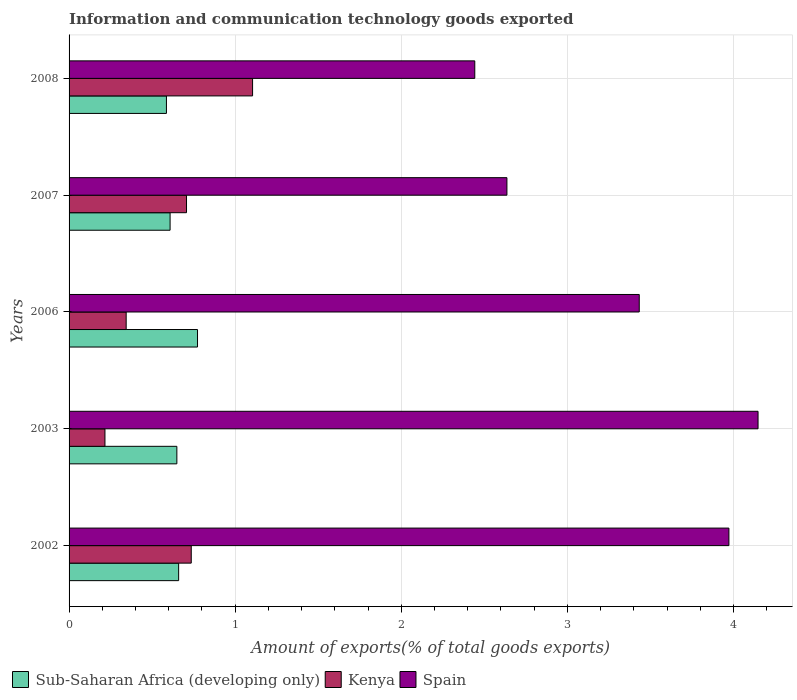How many groups of bars are there?
Provide a short and direct response. 5. Are the number of bars on each tick of the Y-axis equal?
Offer a terse response. Yes. How many bars are there on the 4th tick from the bottom?
Your answer should be compact. 3. What is the amount of goods exported in Sub-Saharan Africa (developing only) in 2002?
Provide a succinct answer. 0.66. Across all years, what is the maximum amount of goods exported in Sub-Saharan Africa (developing only)?
Keep it short and to the point. 0.77. Across all years, what is the minimum amount of goods exported in Spain?
Offer a terse response. 2.44. In which year was the amount of goods exported in Spain minimum?
Keep it short and to the point. 2008. What is the total amount of goods exported in Kenya in the graph?
Your answer should be compact. 3.11. What is the difference between the amount of goods exported in Kenya in 2002 and that in 2006?
Make the answer very short. 0.39. What is the difference between the amount of goods exported in Spain in 2008 and the amount of goods exported in Sub-Saharan Africa (developing only) in 2002?
Provide a short and direct response. 1.78. What is the average amount of goods exported in Kenya per year?
Offer a terse response. 0.62. In the year 2002, what is the difference between the amount of goods exported in Sub-Saharan Africa (developing only) and amount of goods exported in Kenya?
Provide a succinct answer. -0.08. In how many years, is the amount of goods exported in Spain greater than 3 %?
Give a very brief answer. 3. What is the ratio of the amount of goods exported in Kenya in 2002 to that in 2003?
Offer a terse response. 3.41. What is the difference between the highest and the second highest amount of goods exported in Sub-Saharan Africa (developing only)?
Keep it short and to the point. 0.11. What is the difference between the highest and the lowest amount of goods exported in Sub-Saharan Africa (developing only)?
Offer a terse response. 0.19. In how many years, is the amount of goods exported in Spain greater than the average amount of goods exported in Spain taken over all years?
Your answer should be compact. 3. What does the 2nd bar from the top in 2003 represents?
Your response must be concise. Kenya. What does the 2nd bar from the bottom in 2003 represents?
Your response must be concise. Kenya. Is it the case that in every year, the sum of the amount of goods exported in Spain and amount of goods exported in Kenya is greater than the amount of goods exported in Sub-Saharan Africa (developing only)?
Provide a short and direct response. Yes. How many bars are there?
Provide a succinct answer. 15. Are all the bars in the graph horizontal?
Keep it short and to the point. Yes. Are the values on the major ticks of X-axis written in scientific E-notation?
Offer a terse response. No. Does the graph contain grids?
Offer a very short reply. Yes. Where does the legend appear in the graph?
Make the answer very short. Bottom left. How many legend labels are there?
Your response must be concise. 3. How are the legend labels stacked?
Offer a terse response. Horizontal. What is the title of the graph?
Offer a terse response. Information and communication technology goods exported. What is the label or title of the X-axis?
Your answer should be very brief. Amount of exports(% of total goods exports). What is the label or title of the Y-axis?
Offer a very short reply. Years. What is the Amount of exports(% of total goods exports) in Sub-Saharan Africa (developing only) in 2002?
Keep it short and to the point. 0.66. What is the Amount of exports(% of total goods exports) in Kenya in 2002?
Ensure brevity in your answer.  0.74. What is the Amount of exports(% of total goods exports) in Spain in 2002?
Keep it short and to the point. 3.97. What is the Amount of exports(% of total goods exports) in Sub-Saharan Africa (developing only) in 2003?
Offer a very short reply. 0.65. What is the Amount of exports(% of total goods exports) of Kenya in 2003?
Your response must be concise. 0.22. What is the Amount of exports(% of total goods exports) of Spain in 2003?
Give a very brief answer. 4.15. What is the Amount of exports(% of total goods exports) in Sub-Saharan Africa (developing only) in 2006?
Your answer should be compact. 0.77. What is the Amount of exports(% of total goods exports) of Kenya in 2006?
Offer a very short reply. 0.34. What is the Amount of exports(% of total goods exports) of Spain in 2006?
Keep it short and to the point. 3.43. What is the Amount of exports(% of total goods exports) in Sub-Saharan Africa (developing only) in 2007?
Ensure brevity in your answer.  0.61. What is the Amount of exports(% of total goods exports) in Kenya in 2007?
Keep it short and to the point. 0.71. What is the Amount of exports(% of total goods exports) of Spain in 2007?
Keep it short and to the point. 2.64. What is the Amount of exports(% of total goods exports) of Sub-Saharan Africa (developing only) in 2008?
Keep it short and to the point. 0.59. What is the Amount of exports(% of total goods exports) in Kenya in 2008?
Your answer should be compact. 1.1. What is the Amount of exports(% of total goods exports) of Spain in 2008?
Keep it short and to the point. 2.44. Across all years, what is the maximum Amount of exports(% of total goods exports) of Sub-Saharan Africa (developing only)?
Your answer should be compact. 0.77. Across all years, what is the maximum Amount of exports(% of total goods exports) of Kenya?
Your response must be concise. 1.1. Across all years, what is the maximum Amount of exports(% of total goods exports) in Spain?
Ensure brevity in your answer.  4.15. Across all years, what is the minimum Amount of exports(% of total goods exports) in Sub-Saharan Africa (developing only)?
Make the answer very short. 0.59. Across all years, what is the minimum Amount of exports(% of total goods exports) of Kenya?
Your response must be concise. 0.22. Across all years, what is the minimum Amount of exports(% of total goods exports) of Spain?
Offer a terse response. 2.44. What is the total Amount of exports(% of total goods exports) in Sub-Saharan Africa (developing only) in the graph?
Provide a short and direct response. 3.28. What is the total Amount of exports(% of total goods exports) in Kenya in the graph?
Keep it short and to the point. 3.11. What is the total Amount of exports(% of total goods exports) in Spain in the graph?
Offer a very short reply. 16.63. What is the difference between the Amount of exports(% of total goods exports) of Sub-Saharan Africa (developing only) in 2002 and that in 2003?
Keep it short and to the point. 0.01. What is the difference between the Amount of exports(% of total goods exports) of Kenya in 2002 and that in 2003?
Provide a short and direct response. 0.52. What is the difference between the Amount of exports(% of total goods exports) of Spain in 2002 and that in 2003?
Offer a very short reply. -0.18. What is the difference between the Amount of exports(% of total goods exports) in Sub-Saharan Africa (developing only) in 2002 and that in 2006?
Provide a short and direct response. -0.11. What is the difference between the Amount of exports(% of total goods exports) in Kenya in 2002 and that in 2006?
Offer a very short reply. 0.39. What is the difference between the Amount of exports(% of total goods exports) in Spain in 2002 and that in 2006?
Provide a short and direct response. 0.54. What is the difference between the Amount of exports(% of total goods exports) of Sub-Saharan Africa (developing only) in 2002 and that in 2007?
Your answer should be compact. 0.05. What is the difference between the Amount of exports(% of total goods exports) in Kenya in 2002 and that in 2007?
Give a very brief answer. 0.03. What is the difference between the Amount of exports(% of total goods exports) in Spain in 2002 and that in 2007?
Your response must be concise. 1.34. What is the difference between the Amount of exports(% of total goods exports) in Sub-Saharan Africa (developing only) in 2002 and that in 2008?
Your answer should be compact. 0.07. What is the difference between the Amount of exports(% of total goods exports) in Kenya in 2002 and that in 2008?
Ensure brevity in your answer.  -0.37. What is the difference between the Amount of exports(% of total goods exports) in Spain in 2002 and that in 2008?
Offer a terse response. 1.53. What is the difference between the Amount of exports(% of total goods exports) of Sub-Saharan Africa (developing only) in 2003 and that in 2006?
Ensure brevity in your answer.  -0.12. What is the difference between the Amount of exports(% of total goods exports) in Kenya in 2003 and that in 2006?
Give a very brief answer. -0.13. What is the difference between the Amount of exports(% of total goods exports) in Spain in 2003 and that in 2006?
Make the answer very short. 0.72. What is the difference between the Amount of exports(% of total goods exports) of Sub-Saharan Africa (developing only) in 2003 and that in 2007?
Make the answer very short. 0.04. What is the difference between the Amount of exports(% of total goods exports) in Kenya in 2003 and that in 2007?
Offer a very short reply. -0.49. What is the difference between the Amount of exports(% of total goods exports) of Spain in 2003 and that in 2007?
Offer a very short reply. 1.51. What is the difference between the Amount of exports(% of total goods exports) in Sub-Saharan Africa (developing only) in 2003 and that in 2008?
Your answer should be very brief. 0.06. What is the difference between the Amount of exports(% of total goods exports) in Kenya in 2003 and that in 2008?
Your answer should be very brief. -0.89. What is the difference between the Amount of exports(% of total goods exports) in Spain in 2003 and that in 2008?
Offer a very short reply. 1.71. What is the difference between the Amount of exports(% of total goods exports) in Sub-Saharan Africa (developing only) in 2006 and that in 2007?
Offer a very short reply. 0.17. What is the difference between the Amount of exports(% of total goods exports) in Kenya in 2006 and that in 2007?
Provide a succinct answer. -0.36. What is the difference between the Amount of exports(% of total goods exports) in Spain in 2006 and that in 2007?
Ensure brevity in your answer.  0.8. What is the difference between the Amount of exports(% of total goods exports) of Sub-Saharan Africa (developing only) in 2006 and that in 2008?
Make the answer very short. 0.19. What is the difference between the Amount of exports(% of total goods exports) in Kenya in 2006 and that in 2008?
Offer a very short reply. -0.76. What is the difference between the Amount of exports(% of total goods exports) of Sub-Saharan Africa (developing only) in 2007 and that in 2008?
Your answer should be very brief. 0.02. What is the difference between the Amount of exports(% of total goods exports) of Kenya in 2007 and that in 2008?
Keep it short and to the point. -0.4. What is the difference between the Amount of exports(% of total goods exports) in Spain in 2007 and that in 2008?
Offer a terse response. 0.19. What is the difference between the Amount of exports(% of total goods exports) of Sub-Saharan Africa (developing only) in 2002 and the Amount of exports(% of total goods exports) of Kenya in 2003?
Make the answer very short. 0.44. What is the difference between the Amount of exports(% of total goods exports) of Sub-Saharan Africa (developing only) in 2002 and the Amount of exports(% of total goods exports) of Spain in 2003?
Keep it short and to the point. -3.49. What is the difference between the Amount of exports(% of total goods exports) of Kenya in 2002 and the Amount of exports(% of total goods exports) of Spain in 2003?
Ensure brevity in your answer.  -3.41. What is the difference between the Amount of exports(% of total goods exports) in Sub-Saharan Africa (developing only) in 2002 and the Amount of exports(% of total goods exports) in Kenya in 2006?
Provide a succinct answer. 0.32. What is the difference between the Amount of exports(% of total goods exports) of Sub-Saharan Africa (developing only) in 2002 and the Amount of exports(% of total goods exports) of Spain in 2006?
Offer a very short reply. -2.77. What is the difference between the Amount of exports(% of total goods exports) in Kenya in 2002 and the Amount of exports(% of total goods exports) in Spain in 2006?
Provide a short and direct response. -2.7. What is the difference between the Amount of exports(% of total goods exports) in Sub-Saharan Africa (developing only) in 2002 and the Amount of exports(% of total goods exports) in Kenya in 2007?
Your answer should be compact. -0.05. What is the difference between the Amount of exports(% of total goods exports) in Sub-Saharan Africa (developing only) in 2002 and the Amount of exports(% of total goods exports) in Spain in 2007?
Make the answer very short. -1.98. What is the difference between the Amount of exports(% of total goods exports) in Kenya in 2002 and the Amount of exports(% of total goods exports) in Spain in 2007?
Your answer should be very brief. -1.9. What is the difference between the Amount of exports(% of total goods exports) of Sub-Saharan Africa (developing only) in 2002 and the Amount of exports(% of total goods exports) of Kenya in 2008?
Keep it short and to the point. -0.45. What is the difference between the Amount of exports(% of total goods exports) in Sub-Saharan Africa (developing only) in 2002 and the Amount of exports(% of total goods exports) in Spain in 2008?
Offer a very short reply. -1.78. What is the difference between the Amount of exports(% of total goods exports) in Kenya in 2002 and the Amount of exports(% of total goods exports) in Spain in 2008?
Your answer should be very brief. -1.71. What is the difference between the Amount of exports(% of total goods exports) in Sub-Saharan Africa (developing only) in 2003 and the Amount of exports(% of total goods exports) in Kenya in 2006?
Your response must be concise. 0.31. What is the difference between the Amount of exports(% of total goods exports) in Sub-Saharan Africa (developing only) in 2003 and the Amount of exports(% of total goods exports) in Spain in 2006?
Your response must be concise. -2.78. What is the difference between the Amount of exports(% of total goods exports) in Kenya in 2003 and the Amount of exports(% of total goods exports) in Spain in 2006?
Ensure brevity in your answer.  -3.22. What is the difference between the Amount of exports(% of total goods exports) of Sub-Saharan Africa (developing only) in 2003 and the Amount of exports(% of total goods exports) of Kenya in 2007?
Your answer should be compact. -0.06. What is the difference between the Amount of exports(% of total goods exports) of Sub-Saharan Africa (developing only) in 2003 and the Amount of exports(% of total goods exports) of Spain in 2007?
Make the answer very short. -1.99. What is the difference between the Amount of exports(% of total goods exports) in Kenya in 2003 and the Amount of exports(% of total goods exports) in Spain in 2007?
Your answer should be very brief. -2.42. What is the difference between the Amount of exports(% of total goods exports) in Sub-Saharan Africa (developing only) in 2003 and the Amount of exports(% of total goods exports) in Kenya in 2008?
Your answer should be very brief. -0.46. What is the difference between the Amount of exports(% of total goods exports) of Sub-Saharan Africa (developing only) in 2003 and the Amount of exports(% of total goods exports) of Spain in 2008?
Your answer should be very brief. -1.79. What is the difference between the Amount of exports(% of total goods exports) in Kenya in 2003 and the Amount of exports(% of total goods exports) in Spain in 2008?
Give a very brief answer. -2.23. What is the difference between the Amount of exports(% of total goods exports) of Sub-Saharan Africa (developing only) in 2006 and the Amount of exports(% of total goods exports) of Kenya in 2007?
Ensure brevity in your answer.  0.07. What is the difference between the Amount of exports(% of total goods exports) in Sub-Saharan Africa (developing only) in 2006 and the Amount of exports(% of total goods exports) in Spain in 2007?
Keep it short and to the point. -1.86. What is the difference between the Amount of exports(% of total goods exports) of Kenya in 2006 and the Amount of exports(% of total goods exports) of Spain in 2007?
Provide a succinct answer. -2.29. What is the difference between the Amount of exports(% of total goods exports) of Sub-Saharan Africa (developing only) in 2006 and the Amount of exports(% of total goods exports) of Kenya in 2008?
Your response must be concise. -0.33. What is the difference between the Amount of exports(% of total goods exports) in Sub-Saharan Africa (developing only) in 2006 and the Amount of exports(% of total goods exports) in Spain in 2008?
Make the answer very short. -1.67. What is the difference between the Amount of exports(% of total goods exports) of Kenya in 2006 and the Amount of exports(% of total goods exports) of Spain in 2008?
Give a very brief answer. -2.1. What is the difference between the Amount of exports(% of total goods exports) of Sub-Saharan Africa (developing only) in 2007 and the Amount of exports(% of total goods exports) of Kenya in 2008?
Offer a very short reply. -0.5. What is the difference between the Amount of exports(% of total goods exports) of Sub-Saharan Africa (developing only) in 2007 and the Amount of exports(% of total goods exports) of Spain in 2008?
Your answer should be compact. -1.83. What is the difference between the Amount of exports(% of total goods exports) in Kenya in 2007 and the Amount of exports(% of total goods exports) in Spain in 2008?
Ensure brevity in your answer.  -1.74. What is the average Amount of exports(% of total goods exports) of Sub-Saharan Africa (developing only) per year?
Offer a very short reply. 0.66. What is the average Amount of exports(% of total goods exports) of Kenya per year?
Your response must be concise. 0.62. What is the average Amount of exports(% of total goods exports) of Spain per year?
Offer a very short reply. 3.33. In the year 2002, what is the difference between the Amount of exports(% of total goods exports) of Sub-Saharan Africa (developing only) and Amount of exports(% of total goods exports) of Kenya?
Offer a terse response. -0.08. In the year 2002, what is the difference between the Amount of exports(% of total goods exports) of Sub-Saharan Africa (developing only) and Amount of exports(% of total goods exports) of Spain?
Keep it short and to the point. -3.31. In the year 2002, what is the difference between the Amount of exports(% of total goods exports) in Kenya and Amount of exports(% of total goods exports) in Spain?
Your answer should be compact. -3.24. In the year 2003, what is the difference between the Amount of exports(% of total goods exports) of Sub-Saharan Africa (developing only) and Amount of exports(% of total goods exports) of Kenya?
Ensure brevity in your answer.  0.43. In the year 2003, what is the difference between the Amount of exports(% of total goods exports) in Sub-Saharan Africa (developing only) and Amount of exports(% of total goods exports) in Spain?
Provide a short and direct response. -3.5. In the year 2003, what is the difference between the Amount of exports(% of total goods exports) in Kenya and Amount of exports(% of total goods exports) in Spain?
Ensure brevity in your answer.  -3.93. In the year 2006, what is the difference between the Amount of exports(% of total goods exports) of Sub-Saharan Africa (developing only) and Amount of exports(% of total goods exports) of Kenya?
Ensure brevity in your answer.  0.43. In the year 2006, what is the difference between the Amount of exports(% of total goods exports) in Sub-Saharan Africa (developing only) and Amount of exports(% of total goods exports) in Spain?
Offer a terse response. -2.66. In the year 2006, what is the difference between the Amount of exports(% of total goods exports) in Kenya and Amount of exports(% of total goods exports) in Spain?
Provide a short and direct response. -3.09. In the year 2007, what is the difference between the Amount of exports(% of total goods exports) in Sub-Saharan Africa (developing only) and Amount of exports(% of total goods exports) in Kenya?
Make the answer very short. -0.1. In the year 2007, what is the difference between the Amount of exports(% of total goods exports) in Sub-Saharan Africa (developing only) and Amount of exports(% of total goods exports) in Spain?
Your answer should be very brief. -2.03. In the year 2007, what is the difference between the Amount of exports(% of total goods exports) in Kenya and Amount of exports(% of total goods exports) in Spain?
Make the answer very short. -1.93. In the year 2008, what is the difference between the Amount of exports(% of total goods exports) in Sub-Saharan Africa (developing only) and Amount of exports(% of total goods exports) in Kenya?
Your response must be concise. -0.52. In the year 2008, what is the difference between the Amount of exports(% of total goods exports) of Sub-Saharan Africa (developing only) and Amount of exports(% of total goods exports) of Spain?
Provide a short and direct response. -1.86. In the year 2008, what is the difference between the Amount of exports(% of total goods exports) in Kenya and Amount of exports(% of total goods exports) in Spain?
Your answer should be very brief. -1.34. What is the ratio of the Amount of exports(% of total goods exports) in Sub-Saharan Africa (developing only) in 2002 to that in 2003?
Keep it short and to the point. 1.02. What is the ratio of the Amount of exports(% of total goods exports) of Kenya in 2002 to that in 2003?
Your answer should be very brief. 3.41. What is the ratio of the Amount of exports(% of total goods exports) in Spain in 2002 to that in 2003?
Offer a terse response. 0.96. What is the ratio of the Amount of exports(% of total goods exports) in Sub-Saharan Africa (developing only) in 2002 to that in 2006?
Make the answer very short. 0.85. What is the ratio of the Amount of exports(% of total goods exports) in Kenya in 2002 to that in 2006?
Provide a short and direct response. 2.14. What is the ratio of the Amount of exports(% of total goods exports) of Spain in 2002 to that in 2006?
Keep it short and to the point. 1.16. What is the ratio of the Amount of exports(% of total goods exports) in Sub-Saharan Africa (developing only) in 2002 to that in 2007?
Offer a very short reply. 1.08. What is the ratio of the Amount of exports(% of total goods exports) of Kenya in 2002 to that in 2007?
Your answer should be compact. 1.04. What is the ratio of the Amount of exports(% of total goods exports) of Spain in 2002 to that in 2007?
Offer a very short reply. 1.51. What is the ratio of the Amount of exports(% of total goods exports) in Sub-Saharan Africa (developing only) in 2002 to that in 2008?
Give a very brief answer. 1.13. What is the ratio of the Amount of exports(% of total goods exports) in Kenya in 2002 to that in 2008?
Your response must be concise. 0.67. What is the ratio of the Amount of exports(% of total goods exports) in Spain in 2002 to that in 2008?
Offer a very short reply. 1.63. What is the ratio of the Amount of exports(% of total goods exports) in Sub-Saharan Africa (developing only) in 2003 to that in 2006?
Your answer should be compact. 0.84. What is the ratio of the Amount of exports(% of total goods exports) of Kenya in 2003 to that in 2006?
Make the answer very short. 0.63. What is the ratio of the Amount of exports(% of total goods exports) in Spain in 2003 to that in 2006?
Offer a terse response. 1.21. What is the ratio of the Amount of exports(% of total goods exports) of Sub-Saharan Africa (developing only) in 2003 to that in 2007?
Your answer should be very brief. 1.07. What is the ratio of the Amount of exports(% of total goods exports) of Kenya in 2003 to that in 2007?
Offer a terse response. 0.31. What is the ratio of the Amount of exports(% of total goods exports) of Spain in 2003 to that in 2007?
Ensure brevity in your answer.  1.57. What is the ratio of the Amount of exports(% of total goods exports) in Sub-Saharan Africa (developing only) in 2003 to that in 2008?
Provide a short and direct response. 1.11. What is the ratio of the Amount of exports(% of total goods exports) of Kenya in 2003 to that in 2008?
Make the answer very short. 0.2. What is the ratio of the Amount of exports(% of total goods exports) of Spain in 2003 to that in 2008?
Your response must be concise. 1.7. What is the ratio of the Amount of exports(% of total goods exports) in Sub-Saharan Africa (developing only) in 2006 to that in 2007?
Offer a terse response. 1.27. What is the ratio of the Amount of exports(% of total goods exports) of Kenya in 2006 to that in 2007?
Provide a short and direct response. 0.49. What is the ratio of the Amount of exports(% of total goods exports) of Spain in 2006 to that in 2007?
Ensure brevity in your answer.  1.3. What is the ratio of the Amount of exports(% of total goods exports) of Sub-Saharan Africa (developing only) in 2006 to that in 2008?
Offer a very short reply. 1.32. What is the ratio of the Amount of exports(% of total goods exports) in Kenya in 2006 to that in 2008?
Your answer should be compact. 0.31. What is the ratio of the Amount of exports(% of total goods exports) in Spain in 2006 to that in 2008?
Offer a terse response. 1.41. What is the ratio of the Amount of exports(% of total goods exports) of Sub-Saharan Africa (developing only) in 2007 to that in 2008?
Your answer should be very brief. 1.04. What is the ratio of the Amount of exports(% of total goods exports) of Kenya in 2007 to that in 2008?
Provide a succinct answer. 0.64. What is the ratio of the Amount of exports(% of total goods exports) of Spain in 2007 to that in 2008?
Your answer should be very brief. 1.08. What is the difference between the highest and the second highest Amount of exports(% of total goods exports) in Sub-Saharan Africa (developing only)?
Your answer should be very brief. 0.11. What is the difference between the highest and the second highest Amount of exports(% of total goods exports) in Kenya?
Provide a short and direct response. 0.37. What is the difference between the highest and the second highest Amount of exports(% of total goods exports) of Spain?
Provide a succinct answer. 0.18. What is the difference between the highest and the lowest Amount of exports(% of total goods exports) of Sub-Saharan Africa (developing only)?
Ensure brevity in your answer.  0.19. What is the difference between the highest and the lowest Amount of exports(% of total goods exports) in Kenya?
Give a very brief answer. 0.89. What is the difference between the highest and the lowest Amount of exports(% of total goods exports) in Spain?
Your answer should be compact. 1.71. 